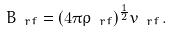Convert formula to latex. <formula><loc_0><loc_0><loc_500><loc_500>B _ { \ r f } = ( 4 \pi \rho _ { \ r f } ) ^ { \frac { 1 } { 2 } } v _ { \ r f } \, .</formula> 